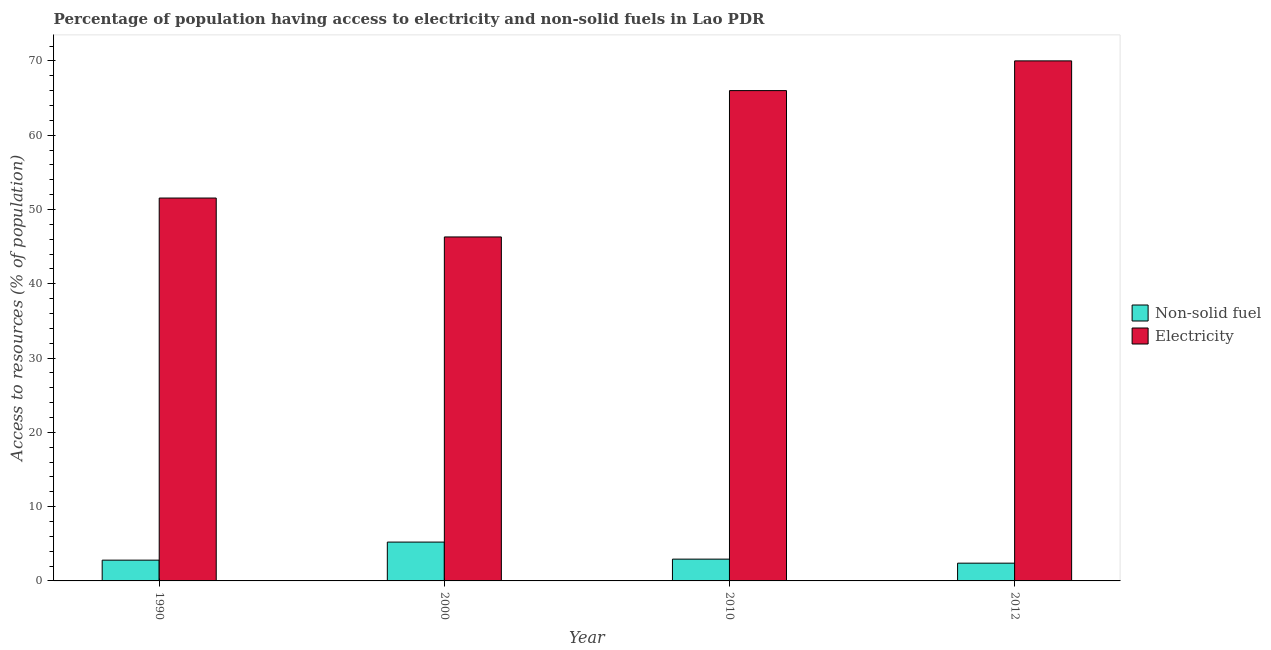How many different coloured bars are there?
Your response must be concise. 2. Are the number of bars per tick equal to the number of legend labels?
Ensure brevity in your answer.  Yes. Are the number of bars on each tick of the X-axis equal?
Offer a terse response. Yes. How many bars are there on the 1st tick from the left?
Make the answer very short. 2. How many bars are there on the 1st tick from the right?
Offer a terse response. 2. What is the label of the 1st group of bars from the left?
Ensure brevity in your answer.  1990. In how many cases, is the number of bars for a given year not equal to the number of legend labels?
Ensure brevity in your answer.  0. What is the percentage of population having access to non-solid fuel in 2010?
Ensure brevity in your answer.  2.93. Across all years, what is the maximum percentage of population having access to non-solid fuel?
Your response must be concise. 5.23. Across all years, what is the minimum percentage of population having access to non-solid fuel?
Give a very brief answer. 2.39. In which year was the percentage of population having access to electricity maximum?
Your answer should be compact. 2012. In which year was the percentage of population having access to non-solid fuel minimum?
Offer a terse response. 2012. What is the total percentage of population having access to electricity in the graph?
Keep it short and to the point. 233.84. What is the difference between the percentage of population having access to non-solid fuel in 1990 and that in 2012?
Your response must be concise. 0.41. What is the difference between the percentage of population having access to non-solid fuel in 2012 and the percentage of population having access to electricity in 2010?
Keep it short and to the point. -0.54. What is the average percentage of population having access to electricity per year?
Keep it short and to the point. 58.46. In the year 2000, what is the difference between the percentage of population having access to electricity and percentage of population having access to non-solid fuel?
Your answer should be very brief. 0. In how many years, is the percentage of population having access to non-solid fuel greater than 20 %?
Make the answer very short. 0. What is the ratio of the percentage of population having access to non-solid fuel in 2010 to that in 2012?
Your answer should be compact. 1.23. Is the percentage of population having access to non-solid fuel in 2010 less than that in 2012?
Make the answer very short. No. What is the difference between the highest and the second highest percentage of population having access to non-solid fuel?
Provide a short and direct response. 2.3. What is the difference between the highest and the lowest percentage of population having access to non-solid fuel?
Offer a terse response. 2.84. In how many years, is the percentage of population having access to non-solid fuel greater than the average percentage of population having access to non-solid fuel taken over all years?
Give a very brief answer. 1. Is the sum of the percentage of population having access to non-solid fuel in 1990 and 2000 greater than the maximum percentage of population having access to electricity across all years?
Give a very brief answer. Yes. What does the 2nd bar from the left in 2000 represents?
Your response must be concise. Electricity. What does the 2nd bar from the right in 2000 represents?
Ensure brevity in your answer.  Non-solid fuel. How many bars are there?
Keep it short and to the point. 8. How many years are there in the graph?
Your response must be concise. 4. What is the difference between two consecutive major ticks on the Y-axis?
Ensure brevity in your answer.  10. Are the values on the major ticks of Y-axis written in scientific E-notation?
Ensure brevity in your answer.  No. Does the graph contain any zero values?
Your answer should be compact. No. Where does the legend appear in the graph?
Provide a short and direct response. Center right. How many legend labels are there?
Offer a terse response. 2. How are the legend labels stacked?
Your answer should be very brief. Vertical. What is the title of the graph?
Offer a terse response. Percentage of population having access to electricity and non-solid fuels in Lao PDR. What is the label or title of the X-axis?
Offer a very short reply. Year. What is the label or title of the Y-axis?
Offer a terse response. Access to resources (% of population). What is the Access to resources (% of population) in Non-solid fuel in 1990?
Ensure brevity in your answer.  2.8. What is the Access to resources (% of population) in Electricity in 1990?
Your answer should be compact. 51.54. What is the Access to resources (% of population) in Non-solid fuel in 2000?
Your response must be concise. 5.23. What is the Access to resources (% of population) in Electricity in 2000?
Your answer should be very brief. 46.3. What is the Access to resources (% of population) of Non-solid fuel in 2010?
Your answer should be very brief. 2.93. What is the Access to resources (% of population) in Non-solid fuel in 2012?
Keep it short and to the point. 2.39. What is the Access to resources (% of population) in Electricity in 2012?
Provide a short and direct response. 70. Across all years, what is the maximum Access to resources (% of population) in Non-solid fuel?
Make the answer very short. 5.23. Across all years, what is the minimum Access to resources (% of population) in Non-solid fuel?
Ensure brevity in your answer.  2.39. Across all years, what is the minimum Access to resources (% of population) in Electricity?
Your answer should be compact. 46.3. What is the total Access to resources (% of population) in Non-solid fuel in the graph?
Offer a very short reply. 13.35. What is the total Access to resources (% of population) in Electricity in the graph?
Your response must be concise. 233.84. What is the difference between the Access to resources (% of population) of Non-solid fuel in 1990 and that in 2000?
Your response must be concise. -2.43. What is the difference between the Access to resources (% of population) in Electricity in 1990 and that in 2000?
Offer a terse response. 5.24. What is the difference between the Access to resources (% of population) in Non-solid fuel in 1990 and that in 2010?
Your answer should be compact. -0.14. What is the difference between the Access to resources (% of population) in Electricity in 1990 and that in 2010?
Provide a succinct answer. -14.46. What is the difference between the Access to resources (% of population) in Non-solid fuel in 1990 and that in 2012?
Give a very brief answer. 0.41. What is the difference between the Access to resources (% of population) in Electricity in 1990 and that in 2012?
Offer a terse response. -18.46. What is the difference between the Access to resources (% of population) of Non-solid fuel in 2000 and that in 2010?
Keep it short and to the point. 2.3. What is the difference between the Access to resources (% of population) in Electricity in 2000 and that in 2010?
Keep it short and to the point. -19.7. What is the difference between the Access to resources (% of population) in Non-solid fuel in 2000 and that in 2012?
Give a very brief answer. 2.84. What is the difference between the Access to resources (% of population) in Electricity in 2000 and that in 2012?
Ensure brevity in your answer.  -23.7. What is the difference between the Access to resources (% of population) of Non-solid fuel in 2010 and that in 2012?
Offer a very short reply. 0.54. What is the difference between the Access to resources (% of population) in Non-solid fuel in 1990 and the Access to resources (% of population) in Electricity in 2000?
Make the answer very short. -43.5. What is the difference between the Access to resources (% of population) of Non-solid fuel in 1990 and the Access to resources (% of population) of Electricity in 2010?
Your response must be concise. -63.2. What is the difference between the Access to resources (% of population) in Non-solid fuel in 1990 and the Access to resources (% of population) in Electricity in 2012?
Ensure brevity in your answer.  -67.2. What is the difference between the Access to resources (% of population) in Non-solid fuel in 2000 and the Access to resources (% of population) in Electricity in 2010?
Make the answer very short. -60.77. What is the difference between the Access to resources (% of population) in Non-solid fuel in 2000 and the Access to resources (% of population) in Electricity in 2012?
Your answer should be very brief. -64.77. What is the difference between the Access to resources (% of population) in Non-solid fuel in 2010 and the Access to resources (% of population) in Electricity in 2012?
Provide a short and direct response. -67.07. What is the average Access to resources (% of population) in Non-solid fuel per year?
Provide a short and direct response. 3.34. What is the average Access to resources (% of population) of Electricity per year?
Ensure brevity in your answer.  58.46. In the year 1990, what is the difference between the Access to resources (% of population) of Non-solid fuel and Access to resources (% of population) of Electricity?
Your response must be concise. -48.74. In the year 2000, what is the difference between the Access to resources (% of population) in Non-solid fuel and Access to resources (% of population) in Electricity?
Provide a succinct answer. -41.07. In the year 2010, what is the difference between the Access to resources (% of population) in Non-solid fuel and Access to resources (% of population) in Electricity?
Provide a short and direct response. -63.07. In the year 2012, what is the difference between the Access to resources (% of population) of Non-solid fuel and Access to resources (% of population) of Electricity?
Provide a succinct answer. -67.61. What is the ratio of the Access to resources (% of population) of Non-solid fuel in 1990 to that in 2000?
Your response must be concise. 0.54. What is the ratio of the Access to resources (% of population) in Electricity in 1990 to that in 2000?
Offer a very short reply. 1.11. What is the ratio of the Access to resources (% of population) in Non-solid fuel in 1990 to that in 2010?
Keep it short and to the point. 0.95. What is the ratio of the Access to resources (% of population) of Electricity in 1990 to that in 2010?
Give a very brief answer. 0.78. What is the ratio of the Access to resources (% of population) in Non-solid fuel in 1990 to that in 2012?
Offer a very short reply. 1.17. What is the ratio of the Access to resources (% of population) in Electricity in 1990 to that in 2012?
Offer a very short reply. 0.74. What is the ratio of the Access to resources (% of population) of Non-solid fuel in 2000 to that in 2010?
Ensure brevity in your answer.  1.78. What is the ratio of the Access to resources (% of population) of Electricity in 2000 to that in 2010?
Offer a very short reply. 0.7. What is the ratio of the Access to resources (% of population) in Non-solid fuel in 2000 to that in 2012?
Offer a terse response. 2.19. What is the ratio of the Access to resources (% of population) in Electricity in 2000 to that in 2012?
Offer a very short reply. 0.66. What is the ratio of the Access to resources (% of population) of Non-solid fuel in 2010 to that in 2012?
Offer a terse response. 1.23. What is the ratio of the Access to resources (% of population) of Electricity in 2010 to that in 2012?
Make the answer very short. 0.94. What is the difference between the highest and the second highest Access to resources (% of population) in Non-solid fuel?
Make the answer very short. 2.3. What is the difference between the highest and the lowest Access to resources (% of population) in Non-solid fuel?
Give a very brief answer. 2.84. What is the difference between the highest and the lowest Access to resources (% of population) of Electricity?
Your response must be concise. 23.7. 